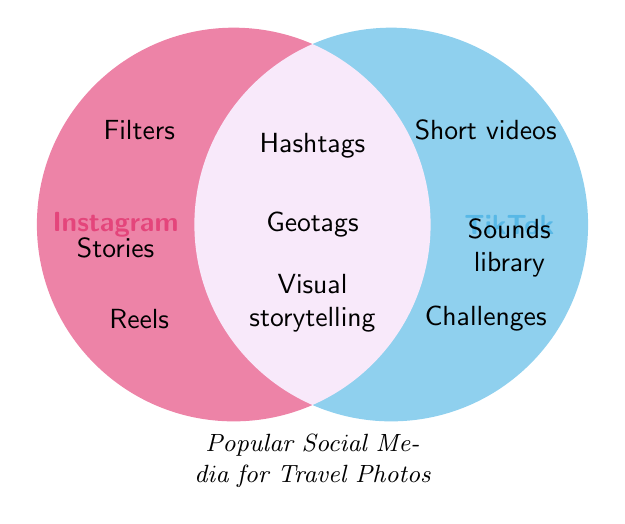What is the title of the Venn Diagram? The title is usually written at the bottom center of the Venn Diagram.
Answer: Popular Social Media for Travel Photos Which platform provides "Filters"? "Filters" is written inside the circle labeled "Instagram".
Answer: Instagram Name one feature that both Instagram and TikTok have in common. Look for the features positioned where the Instagram and TikTok circles overlap.
Answer: Visual storytelling How many features are unique to TikTok? Count the features listed only in the TikTok circle.
Answer: 3 Which platform offers "Geotags"? "Geotags" is listed in the overlapping section of the Venn Diagram, indicating it belongs to both platforms.
Answer: Both What is a feature unique to Instagram that starts with the letter "R"? Look in the Instagram circle for features that start with "R".
Answer: Reels Compare the photo editing tools support on Instagram and TikTok. Which platform offers it? Locate "Photo editing tools" in the Venn Diagram and see which circle it is inside.
Answer: Instagram Does TikTok offer "Duets"? "Duets" is listed under the TikTok circle, indicating it is a feature TikTok offers.
Answer: Yes Is Instagram mobile-optimized? Locate the term "Mobile-optimized" and see it in the circle labeled "Instagram".
Answer: Yes List all the features that TikTok offers but Instagram does not. Identify the features in TikTok's circle that are not in the overlapping section.
Answer: Short videos, Duets, Sounds library, Challenges 